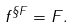<formula> <loc_0><loc_0><loc_500><loc_500>f ^ { \S F } = F .</formula> 